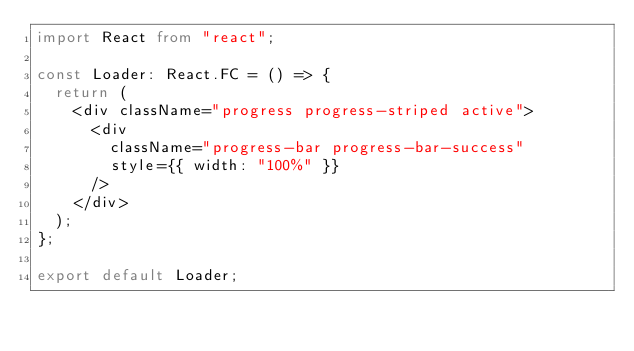Convert code to text. <code><loc_0><loc_0><loc_500><loc_500><_TypeScript_>import React from "react";

const Loader: React.FC = () => {
  return (
    <div className="progress progress-striped active">
      <div
        className="progress-bar progress-bar-success"
        style={{ width: "100%" }}
      />
    </div>
  );
};

export default Loader;
</code> 